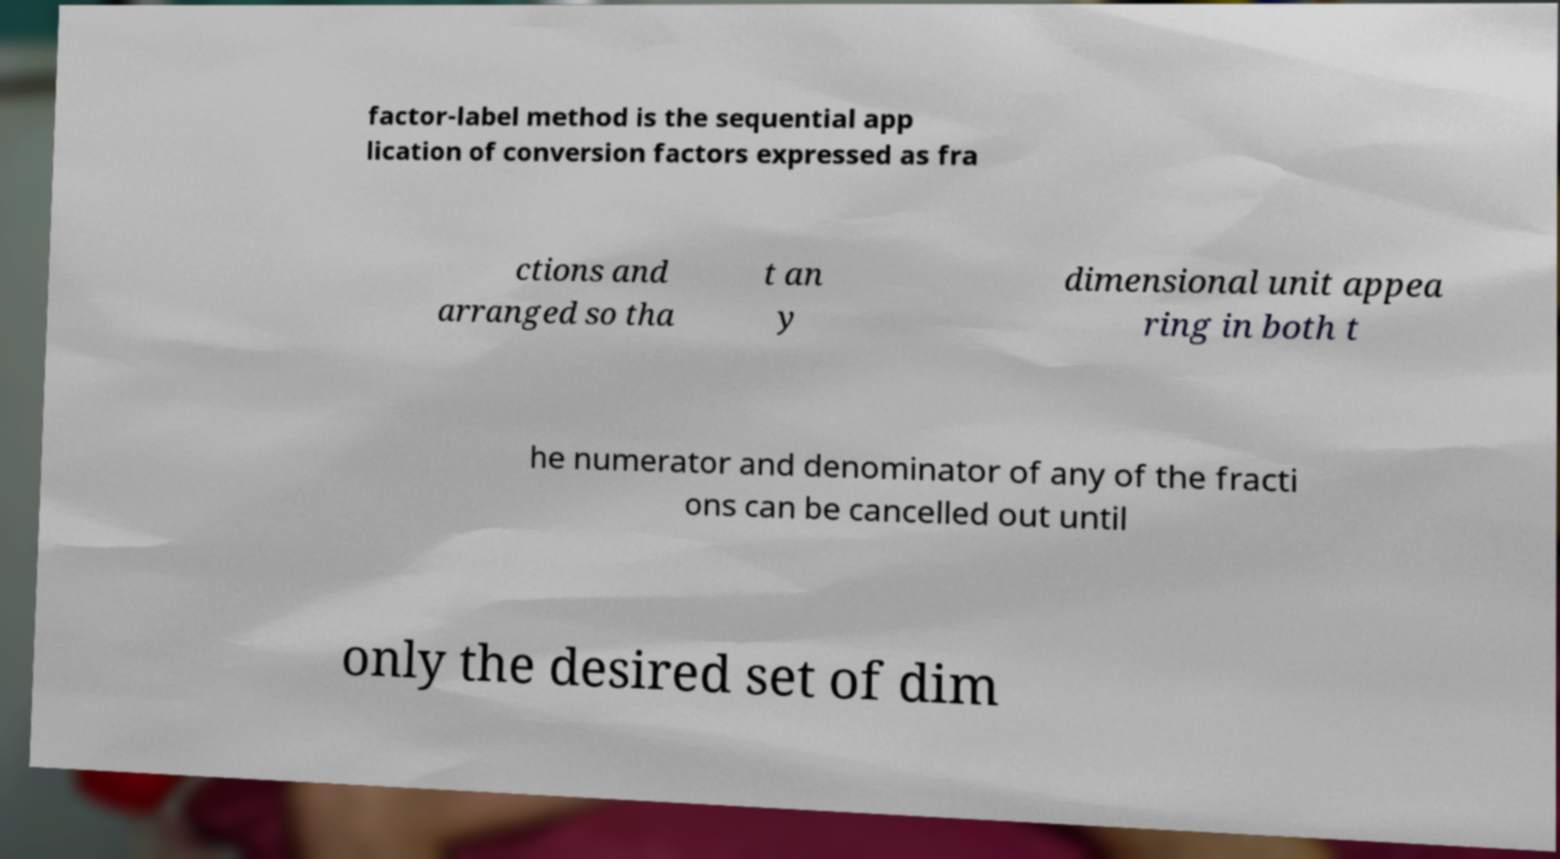Please identify and transcribe the text found in this image. factor-label method is the sequential app lication of conversion factors expressed as fra ctions and arranged so tha t an y dimensional unit appea ring in both t he numerator and denominator of any of the fracti ons can be cancelled out until only the desired set of dim 